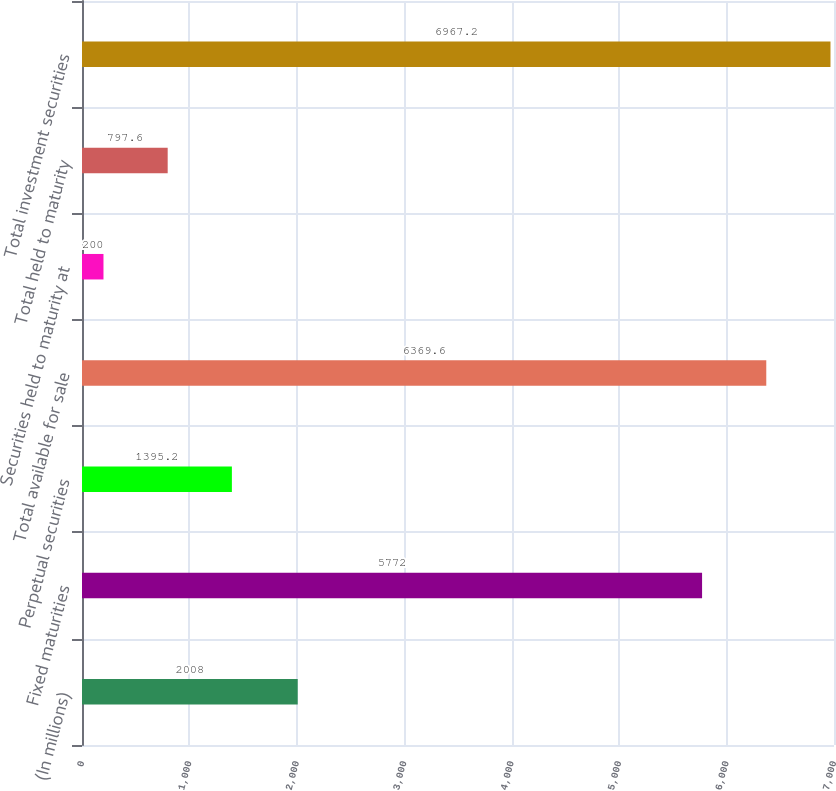<chart> <loc_0><loc_0><loc_500><loc_500><bar_chart><fcel>(In millions)<fcel>Fixed maturities<fcel>Perpetual securities<fcel>Total available for sale<fcel>Securities held to maturity at<fcel>Total held to maturity<fcel>Total investment securities<nl><fcel>2008<fcel>5772<fcel>1395.2<fcel>6369.6<fcel>200<fcel>797.6<fcel>6967.2<nl></chart> 